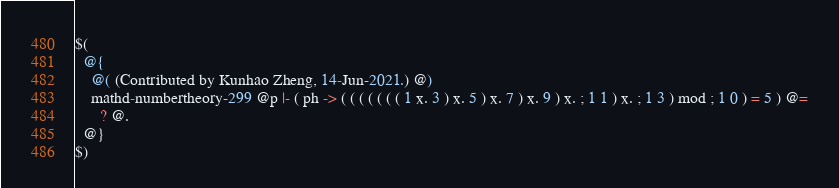<code> <loc_0><loc_0><loc_500><loc_500><_ObjectiveC_>$(
  @{
    @( (Contributed by Kunhao Zheng, 14-Jun-2021.) @)
    mathd-numbertheory-299 @p |- ( ph -> ( ( ( ( ( ( ( 1 x. 3 ) x. 5 ) x. 7 ) x. 9 ) x. ; 1 1 ) x. ; 1 3 ) mod ; 1 0 ) = 5 ) @=
      ? @.
  @}
$)
</code> 